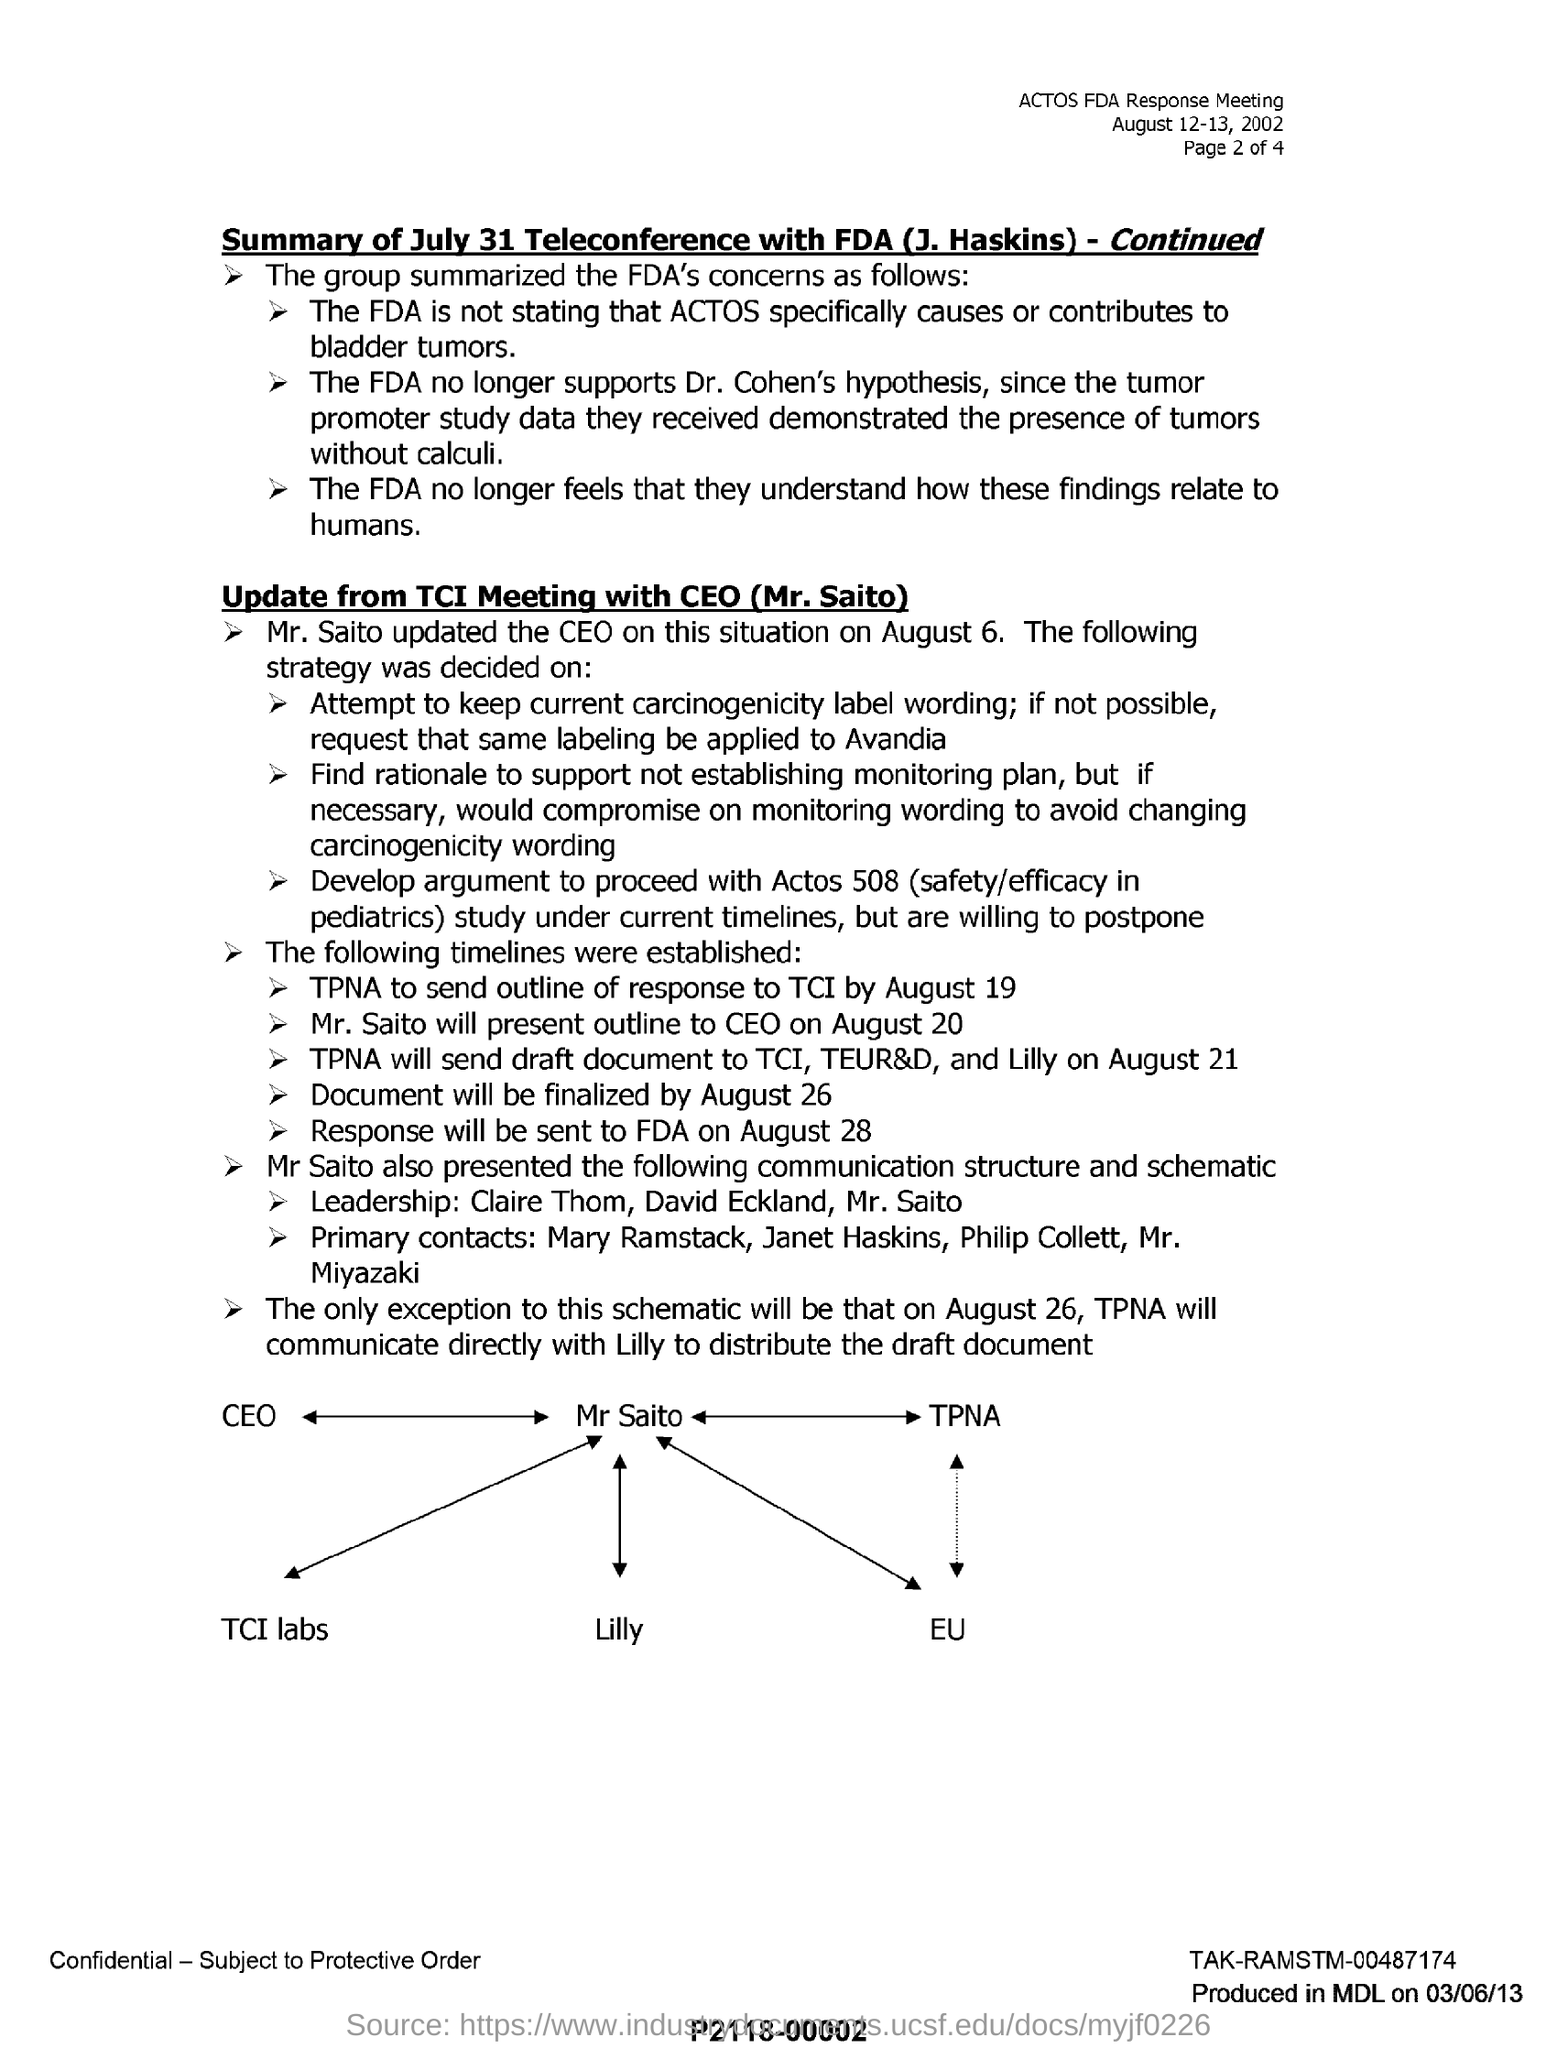Point out several critical features in this image. By August 19, TPNA should send the outline of its response to TCI. The document will be finalized by August 26. The CEO was updated on August 6 by Mr. Saito. Mr. Saito will present an outline to the CEO on August 20th. 